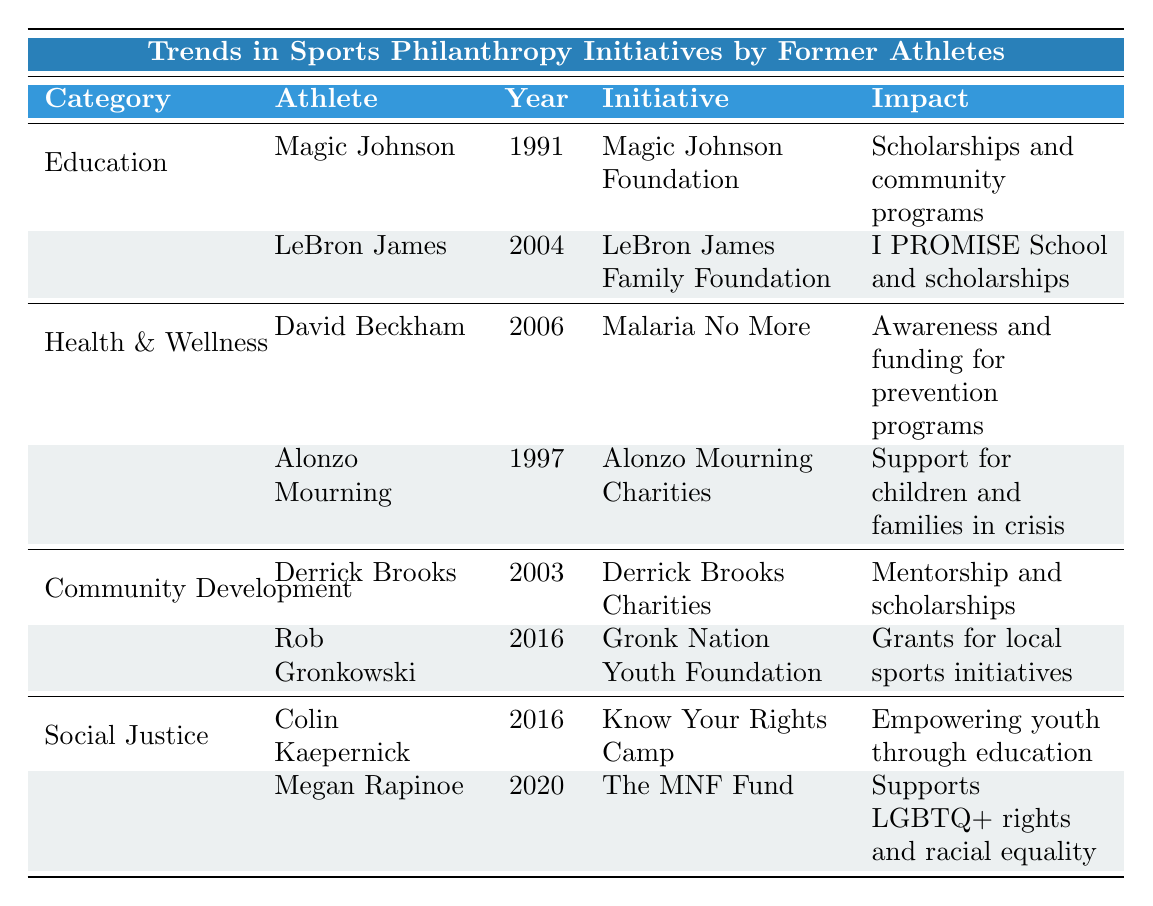What is the focus of the LeBron James Family Foundation? According to the table, the initiative focuses on "Education, especially for at-risk students."
Answer: Education for at-risk students Who established the initiative for malaria prevention? The table shows that David Beckham established the "Malaria No More" initiative in 2006, focusing on health and malaria prevention.
Answer: David Beckham How many initiatives in the "Social Justice" category were established after 2015? There are two initiatives listed in the "Social Justice" category; both Colin Kaepernick's "Know Your Rights Camp" and Megan Rapinoe's "The MNF Fund" were established in 2016 and 2020, respectively. Thus, both qualify.
Answer: 2 Which athlete's initiative has the earliest establishment year in the "Community Development" category? In the "Community Development" category, Derrick Brooks' initiative, established in 2003, is earlier than Rob Gronkowski's, which was established in 2016.
Answer: Derrick Brooks What impact did Magic Johnson's foundation have? The impact listed for the "Magic Johnson Foundation" is "Scholarships and community programs."
Answer: Scholarships and community programs Is there any athlete focusing on health and wellness before the year 2000? The table indicates that Alonzo Mourning established his initiative in 1997, which confirms there is an athlete focusing on health and wellness before 2000.
Answer: Yes Which category has the most initiatives listed in the table? The table shows that each category has two initiatives, resulting in an equal count. Thus, there's no single category with the most initiatives.
Answer: None, equal count What is the main focus of the "MNF Fund" established by Megan Rapinoe? The table states that the "MNF Fund" focuses on "Social justice and gender equity."
Answer: Social justice and gender equity What is the combined impact of the initiatives established by athletes in the "Health & Wellness" category? The two listings in this category have the impacts: "Awareness and funding for prevention programs" and "Support for children and families in crisis." Together, they focus on health and welfare for various vulnerable groups.
Answer: Health and welfare for children and crisis families Which athlete initiated more than one philanthropic effort? From the table, it appears that each athlete listed has only one initiative, indicating none have more than one philanthropic effort among the given data.
Answer: No athlete initiated more than one effort 